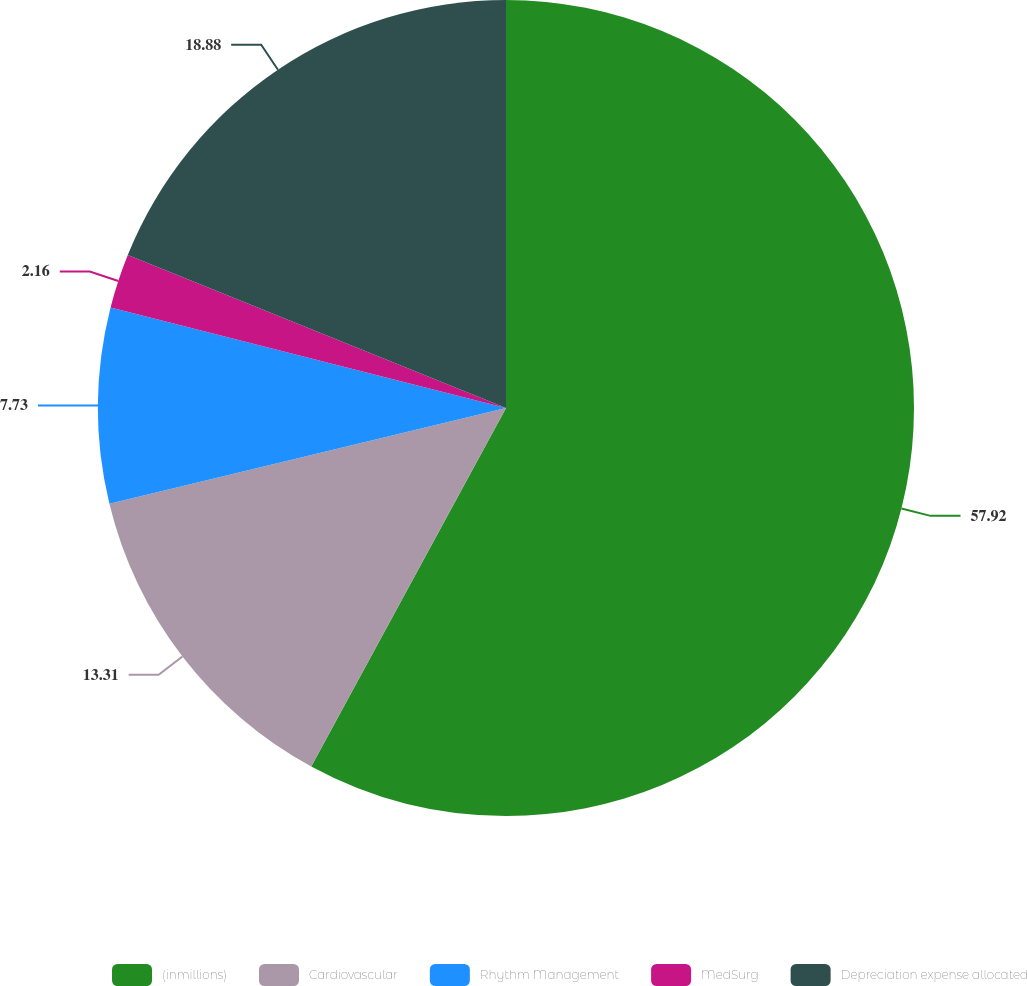Convert chart. <chart><loc_0><loc_0><loc_500><loc_500><pie_chart><fcel>(inmillions)<fcel>Cardiovascular<fcel>Rhythm Management<fcel>MedSurg<fcel>Depreciation expense allocated<nl><fcel>57.92%<fcel>13.31%<fcel>7.73%<fcel>2.16%<fcel>18.88%<nl></chart> 